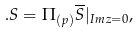Convert formula to latex. <formula><loc_0><loc_0><loc_500><loc_500>. S = \Pi _ { ( p ) } \overline { S } | _ { I m z = 0 } ,</formula> 